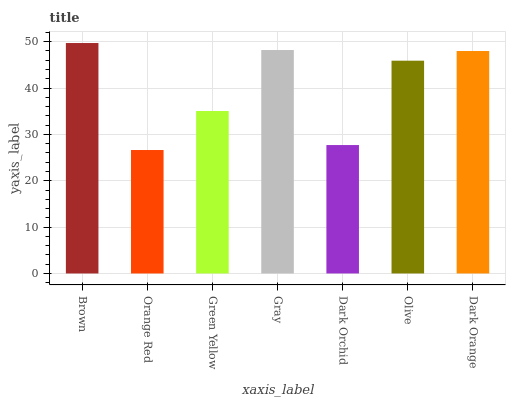Is Orange Red the minimum?
Answer yes or no. Yes. Is Brown the maximum?
Answer yes or no. Yes. Is Green Yellow the minimum?
Answer yes or no. No. Is Green Yellow the maximum?
Answer yes or no. No. Is Green Yellow greater than Orange Red?
Answer yes or no. Yes. Is Orange Red less than Green Yellow?
Answer yes or no. Yes. Is Orange Red greater than Green Yellow?
Answer yes or no. No. Is Green Yellow less than Orange Red?
Answer yes or no. No. Is Olive the high median?
Answer yes or no. Yes. Is Olive the low median?
Answer yes or no. Yes. Is Gray the high median?
Answer yes or no. No. Is Green Yellow the low median?
Answer yes or no. No. 